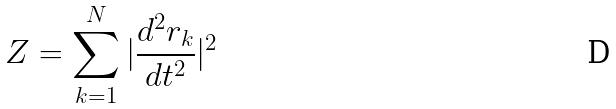Convert formula to latex. <formula><loc_0><loc_0><loc_500><loc_500>Z = \sum _ { k = 1 } ^ { N } | \frac { d ^ { 2 } r _ { k } } { d t ^ { 2 } } | ^ { 2 }</formula> 